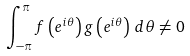Convert formula to latex. <formula><loc_0><loc_0><loc_500><loc_500>\int _ { - \pi } ^ { \pi } f \left ( e ^ { i \theta } \right ) g \left ( e ^ { i \theta } \right ) \, d \theta \not = 0</formula> 